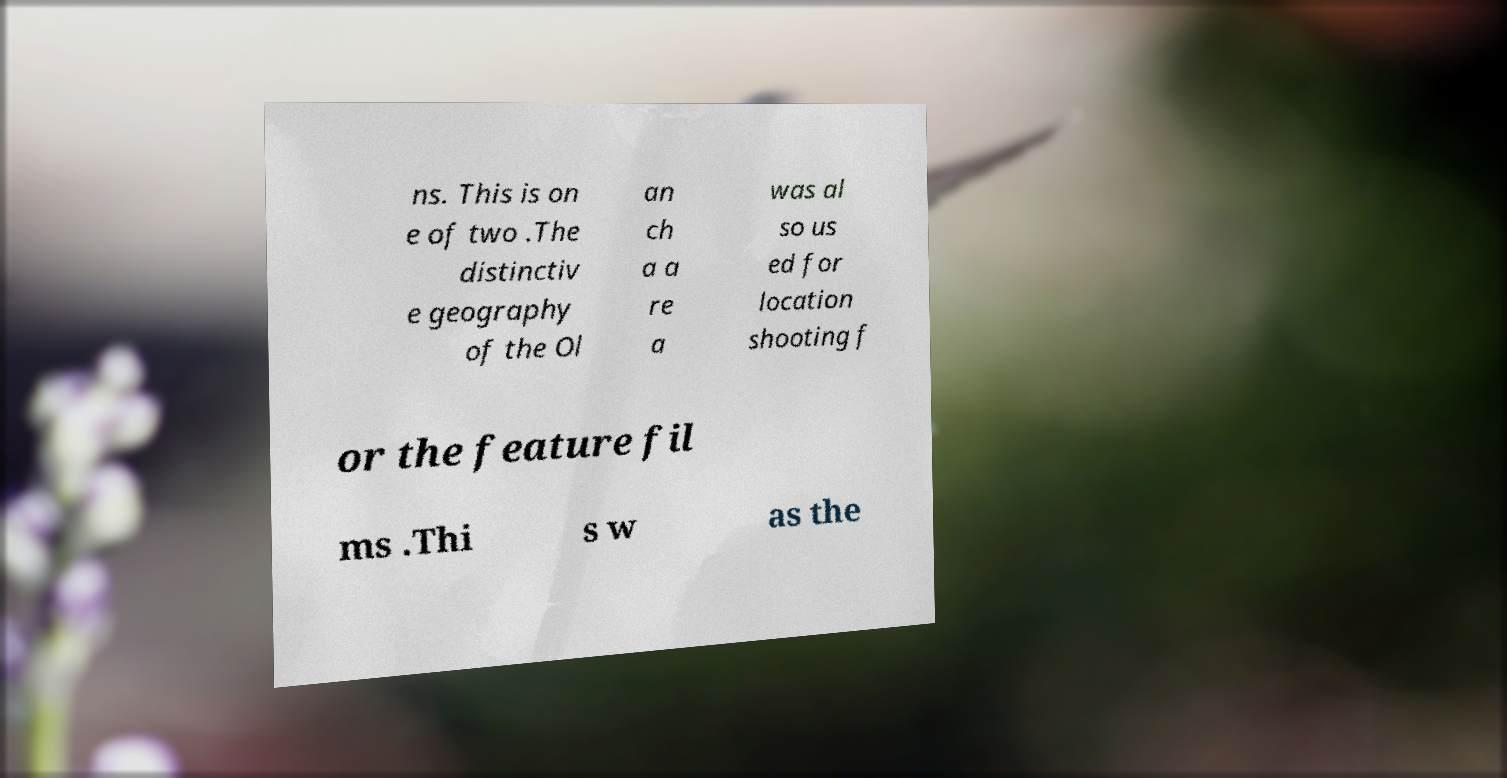For documentation purposes, I need the text within this image transcribed. Could you provide that? ns. This is on e of two .The distinctiv e geography of the Ol an ch a a re a was al so us ed for location shooting f or the feature fil ms .Thi s w as the 